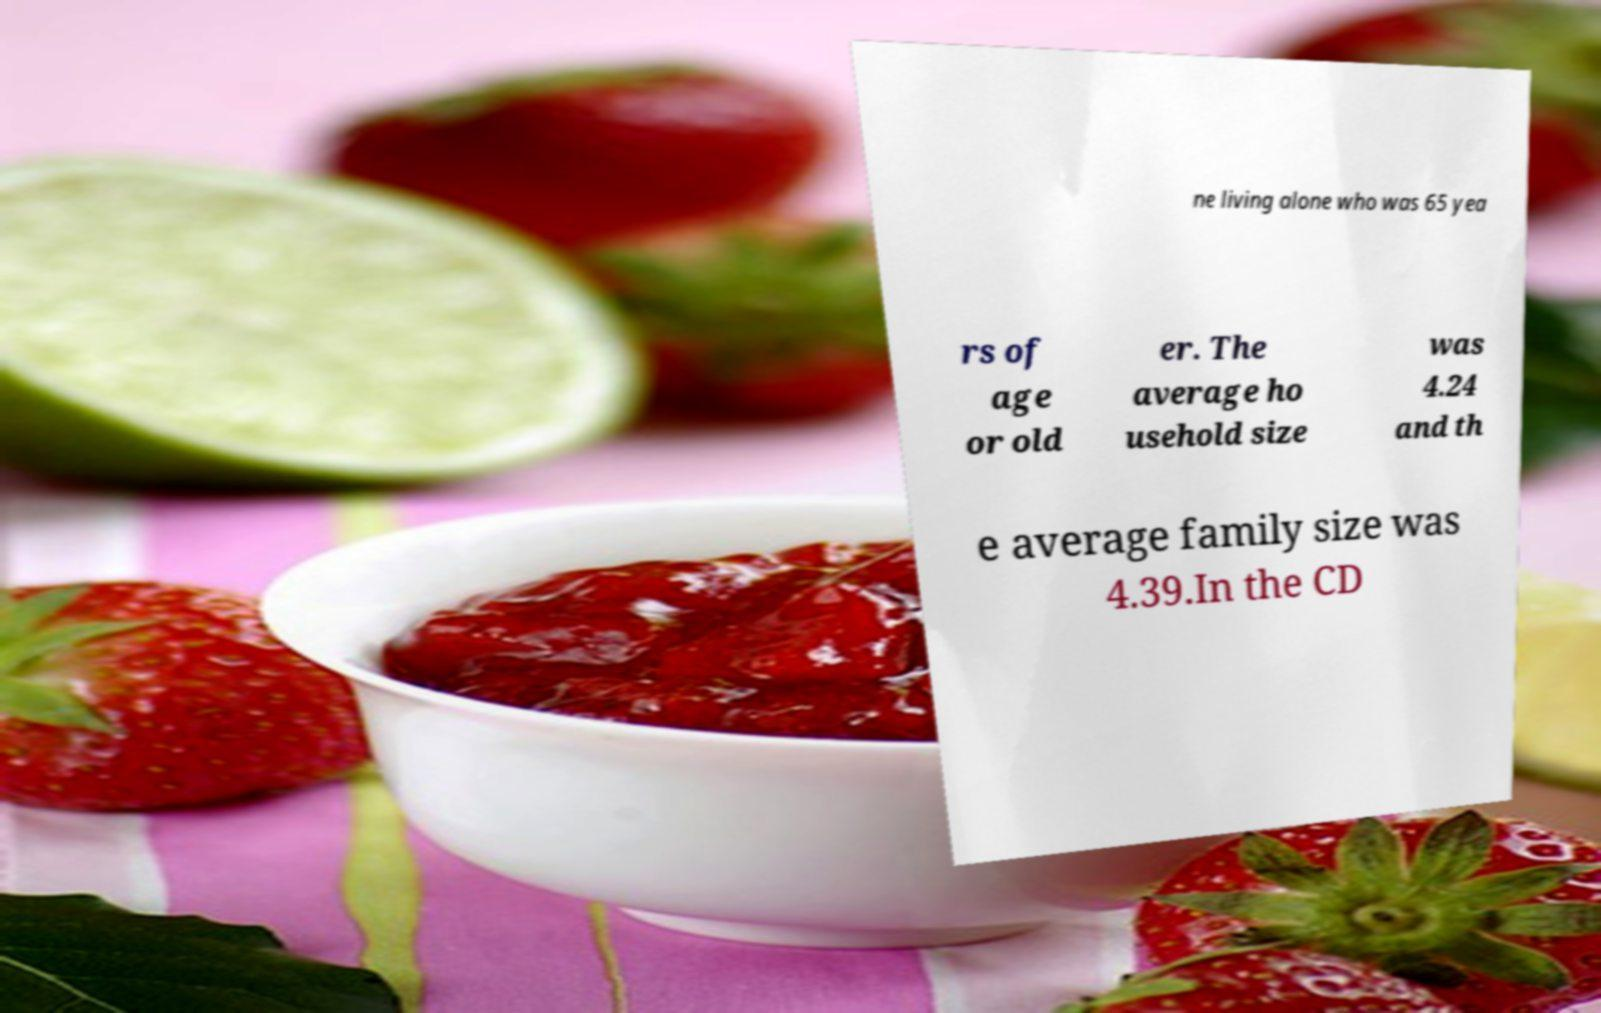What messages or text are displayed in this image? I need them in a readable, typed format. ne living alone who was 65 yea rs of age or old er. The average ho usehold size was 4.24 and th e average family size was 4.39.In the CD 